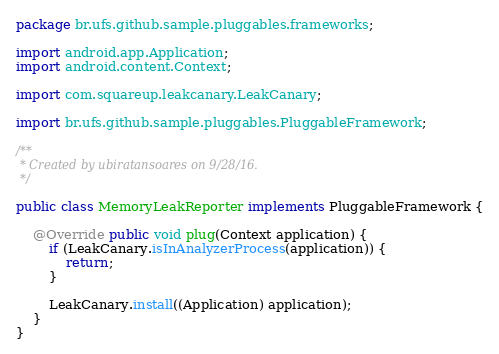Convert code to text. <code><loc_0><loc_0><loc_500><loc_500><_Java_>package br.ufs.github.sample.pluggables.frameworks;

import android.app.Application;
import android.content.Context;

import com.squareup.leakcanary.LeakCanary;

import br.ufs.github.sample.pluggables.PluggableFramework;

/**
 * Created by ubiratansoares on 9/28/16.
 */

public class MemoryLeakReporter implements PluggableFramework {

    @Override public void plug(Context application) {
        if (LeakCanary.isInAnalyzerProcess(application)) {
            return;
        }

        LeakCanary.install((Application) application);
    }
}
</code> 